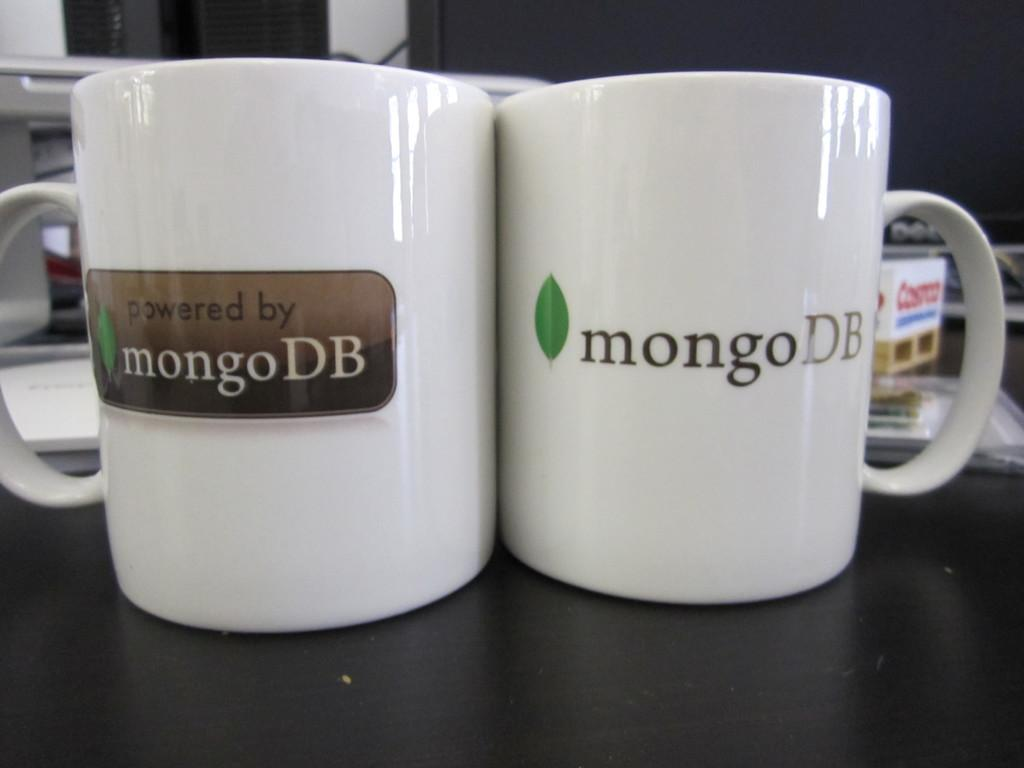<image>
Render a clear and concise summary of the photo. Two white mugs that both say MongoDB on a black table. 